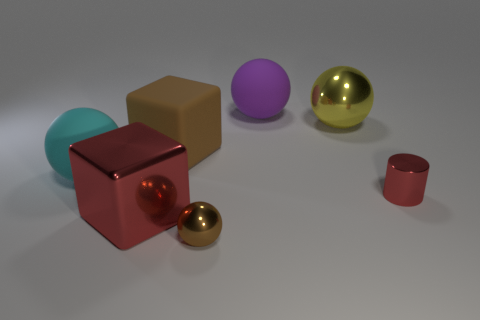The other shiny object that is the same shape as the small brown shiny thing is what color?
Your answer should be compact. Yellow. How many metal objects are either purple things or large cyan spheres?
Provide a short and direct response. 0. There is a big metal object that is left of the large ball on the right side of the purple rubber sphere; are there any big things that are behind it?
Make the answer very short. Yes. The small cylinder has what color?
Make the answer very short. Red. Do the tiny metallic thing to the left of the tiny red thing and the cyan rubber thing have the same shape?
Your answer should be very brief. Yes. How many objects are either large gray metal balls or red metallic objects to the right of the big yellow metallic ball?
Keep it short and to the point. 1. Are the brown thing behind the cyan matte object and the cyan thing made of the same material?
Offer a terse response. Yes. What material is the red object that is to the left of the small thing left of the large purple ball?
Give a very brief answer. Metal. Is the number of metallic things that are to the left of the yellow sphere greater than the number of large purple spheres that are behind the purple matte sphere?
Offer a very short reply. Yes. What size is the brown ball?
Provide a succinct answer. Small. 